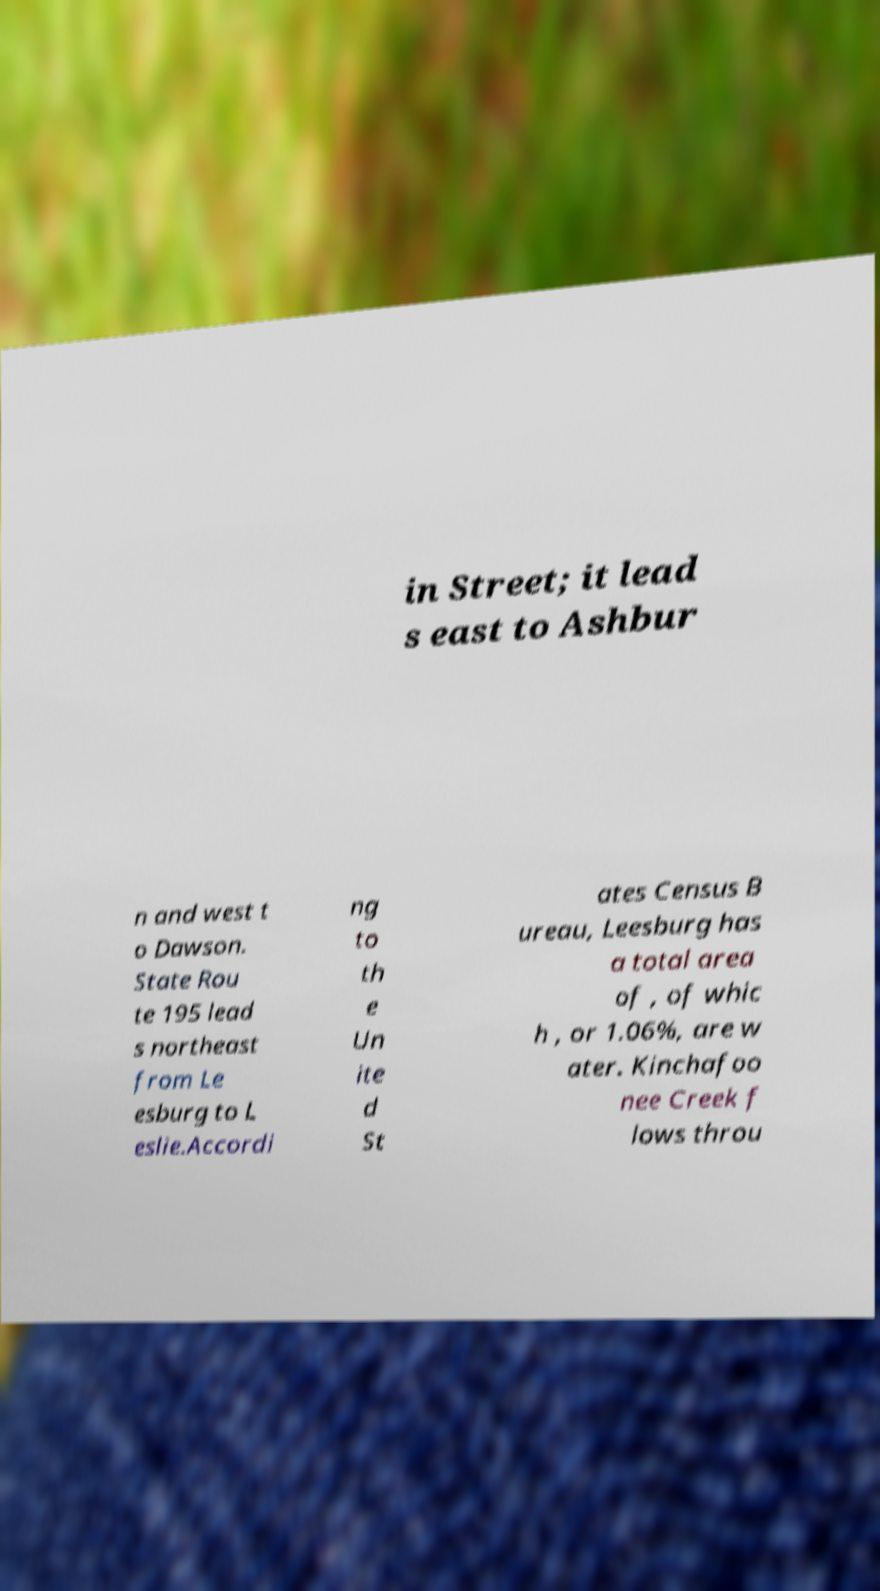There's text embedded in this image that I need extracted. Can you transcribe it verbatim? in Street; it lead s east to Ashbur n and west t o Dawson. State Rou te 195 lead s northeast from Le esburg to L eslie.Accordi ng to th e Un ite d St ates Census B ureau, Leesburg has a total area of , of whic h , or 1.06%, are w ater. Kinchafoo nee Creek f lows throu 